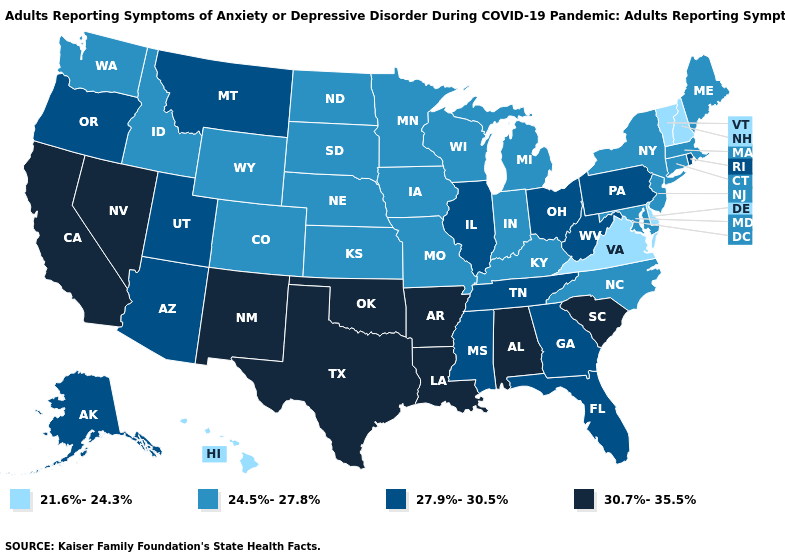Which states have the lowest value in the USA?
Be succinct. Delaware, Hawaii, New Hampshire, Vermont, Virginia. What is the lowest value in the USA?
Be succinct. 21.6%-24.3%. Does the map have missing data?
Short answer required. No. Does Vermont have the highest value in the Northeast?
Short answer required. No. What is the value of Idaho?
Give a very brief answer. 24.5%-27.8%. What is the value of Arkansas?
Write a very short answer. 30.7%-35.5%. Does the first symbol in the legend represent the smallest category?
Be succinct. Yes. Name the states that have a value in the range 21.6%-24.3%?
Keep it brief. Delaware, Hawaii, New Hampshire, Vermont, Virginia. Name the states that have a value in the range 21.6%-24.3%?
Concise answer only. Delaware, Hawaii, New Hampshire, Vermont, Virginia. Name the states that have a value in the range 27.9%-30.5%?
Short answer required. Alaska, Arizona, Florida, Georgia, Illinois, Mississippi, Montana, Ohio, Oregon, Pennsylvania, Rhode Island, Tennessee, Utah, West Virginia. How many symbols are there in the legend?
Be succinct. 4. What is the value of Oregon?
Give a very brief answer. 27.9%-30.5%. Among the states that border Mississippi , does Tennessee have the highest value?
Concise answer only. No. What is the value of Washington?
Short answer required. 24.5%-27.8%. Does the map have missing data?
Write a very short answer. No. 